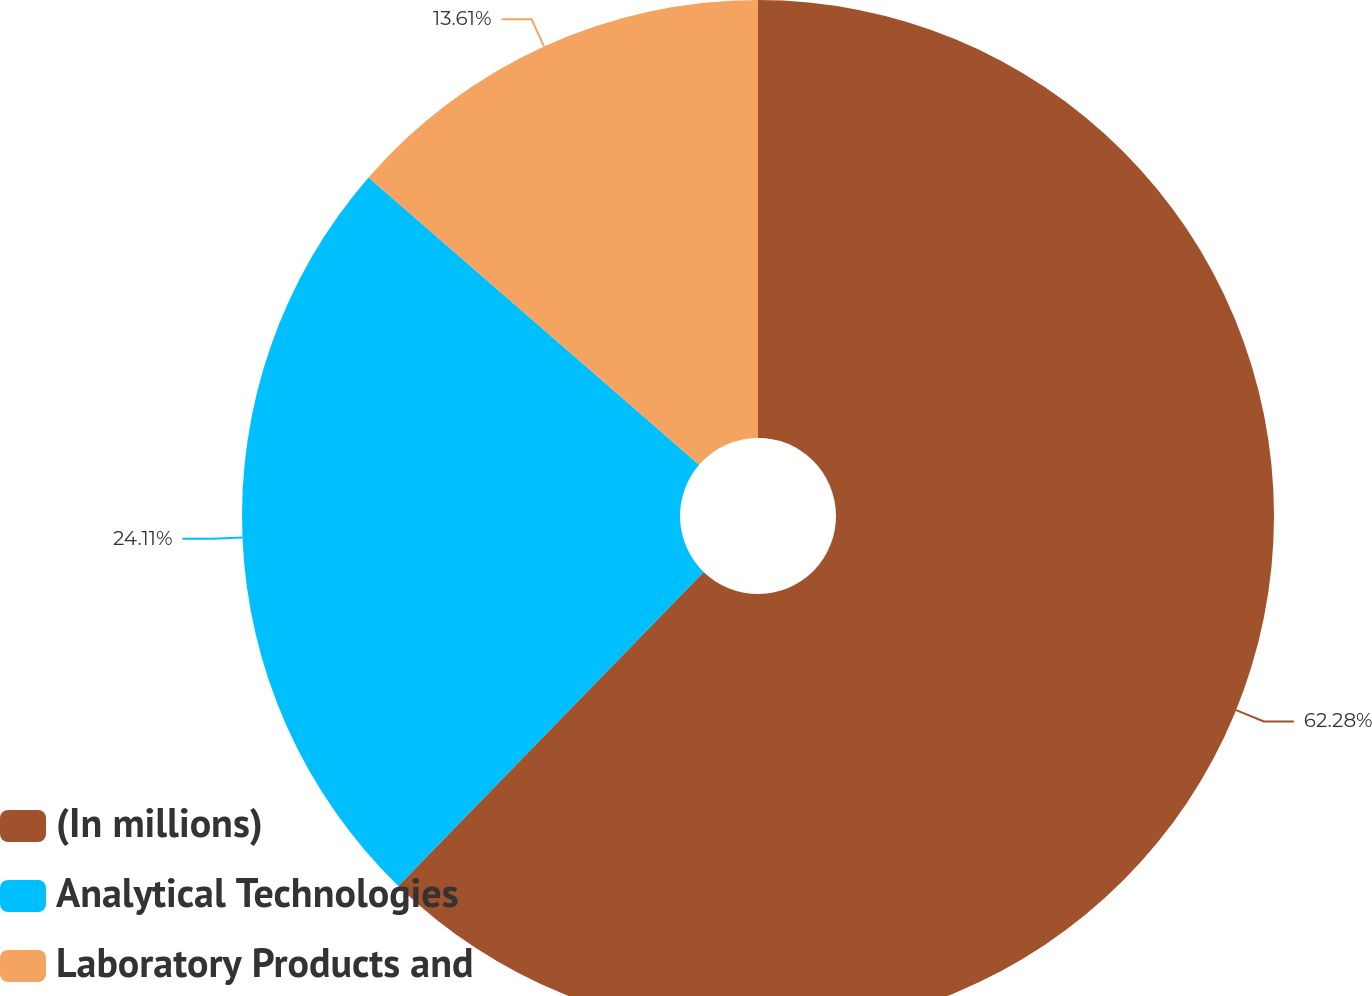<chart> <loc_0><loc_0><loc_500><loc_500><pie_chart><fcel>(In millions)<fcel>Analytical Technologies<fcel>Laboratory Products and<nl><fcel>62.28%<fcel>24.11%<fcel>13.61%<nl></chart> 